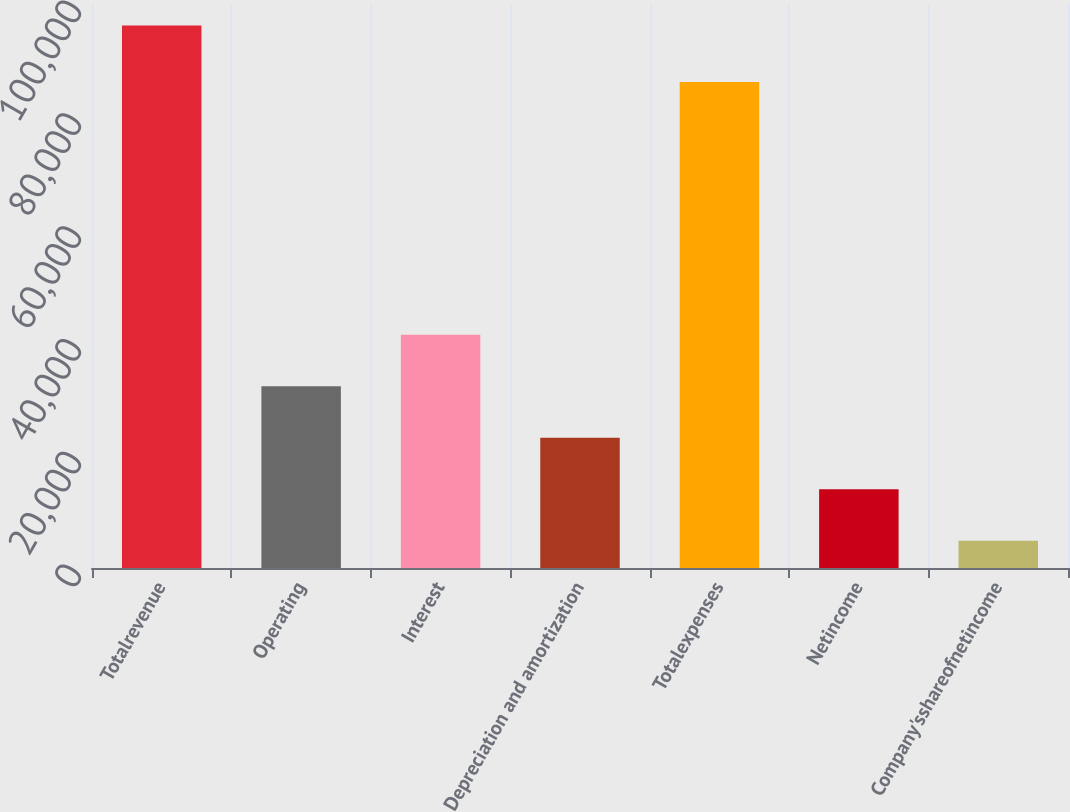Convert chart. <chart><loc_0><loc_0><loc_500><loc_500><bar_chart><fcel>Totalrevenue<fcel>Operating<fcel>Interest<fcel>Depreciation and amortization<fcel>Totalexpenses<fcel>Netincome<fcel>Company'sshareofnetincome<nl><fcel>96189<fcel>32237<fcel>41373<fcel>23101<fcel>86177<fcel>13965<fcel>4829<nl></chart> 